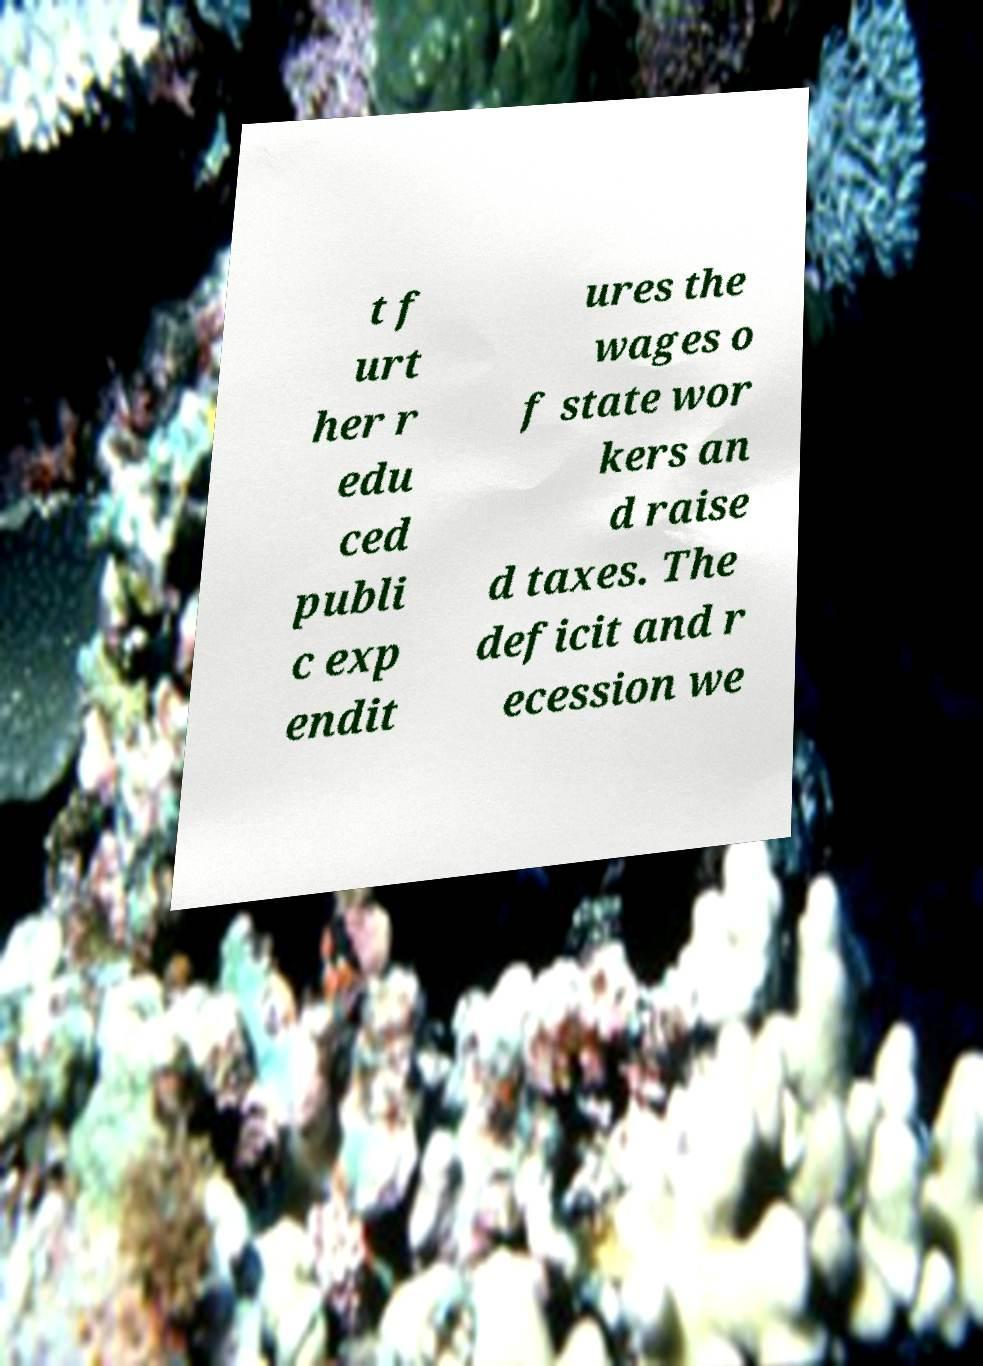Please identify and transcribe the text found in this image. t f urt her r edu ced publi c exp endit ures the wages o f state wor kers an d raise d taxes. The deficit and r ecession we 